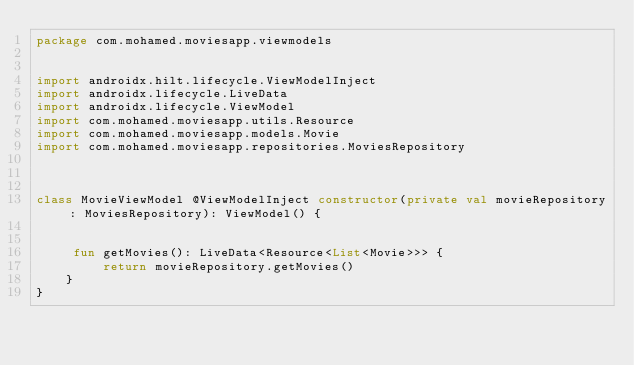<code> <loc_0><loc_0><loc_500><loc_500><_Kotlin_>package com.mohamed.moviesapp.viewmodels


import androidx.hilt.lifecycle.ViewModelInject
import androidx.lifecycle.LiveData
import androidx.lifecycle.ViewModel
import com.mohamed.moviesapp.utils.Resource
import com.mohamed.moviesapp.models.Movie
import com.mohamed.moviesapp.repositories.MoviesRepository



class MovieViewModel @ViewModelInject constructor(private val movieRepository: MoviesRepository): ViewModel() {


     fun getMovies(): LiveData<Resource<List<Movie>>> {
         return movieRepository.getMovies()
    }
}</code> 